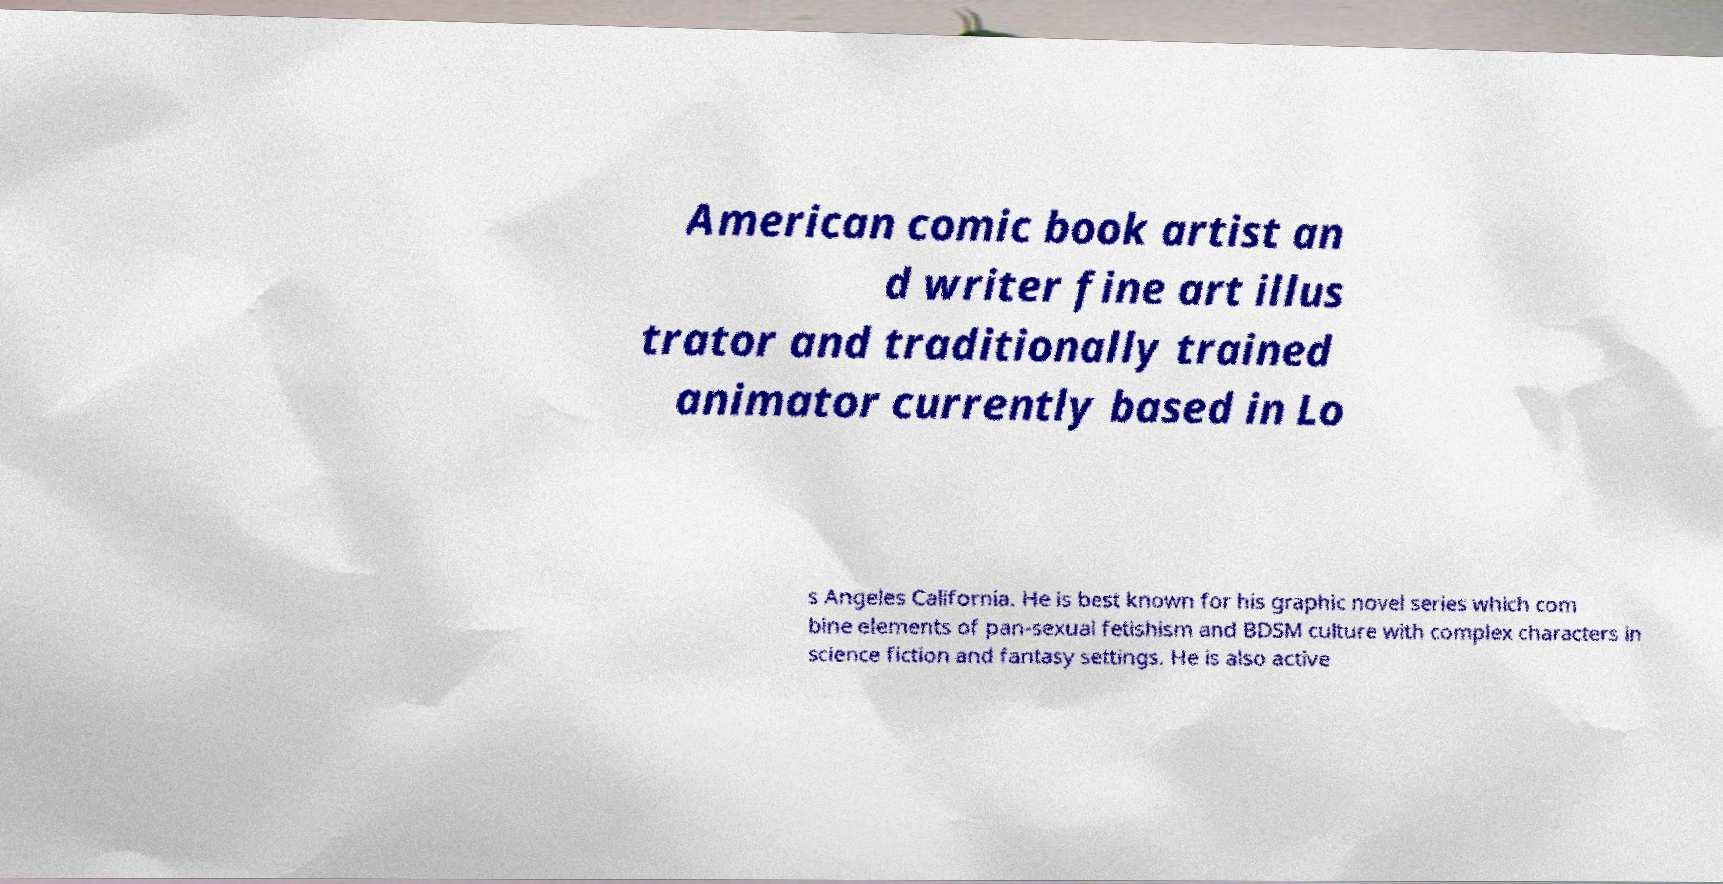I need the written content from this picture converted into text. Can you do that? American comic book artist an d writer fine art illus trator and traditionally trained animator currently based in Lo s Angeles California. He is best known for his graphic novel series which com bine elements of pan-sexual fetishism and BDSM culture with complex characters in science fiction and fantasy settings. He is also active 